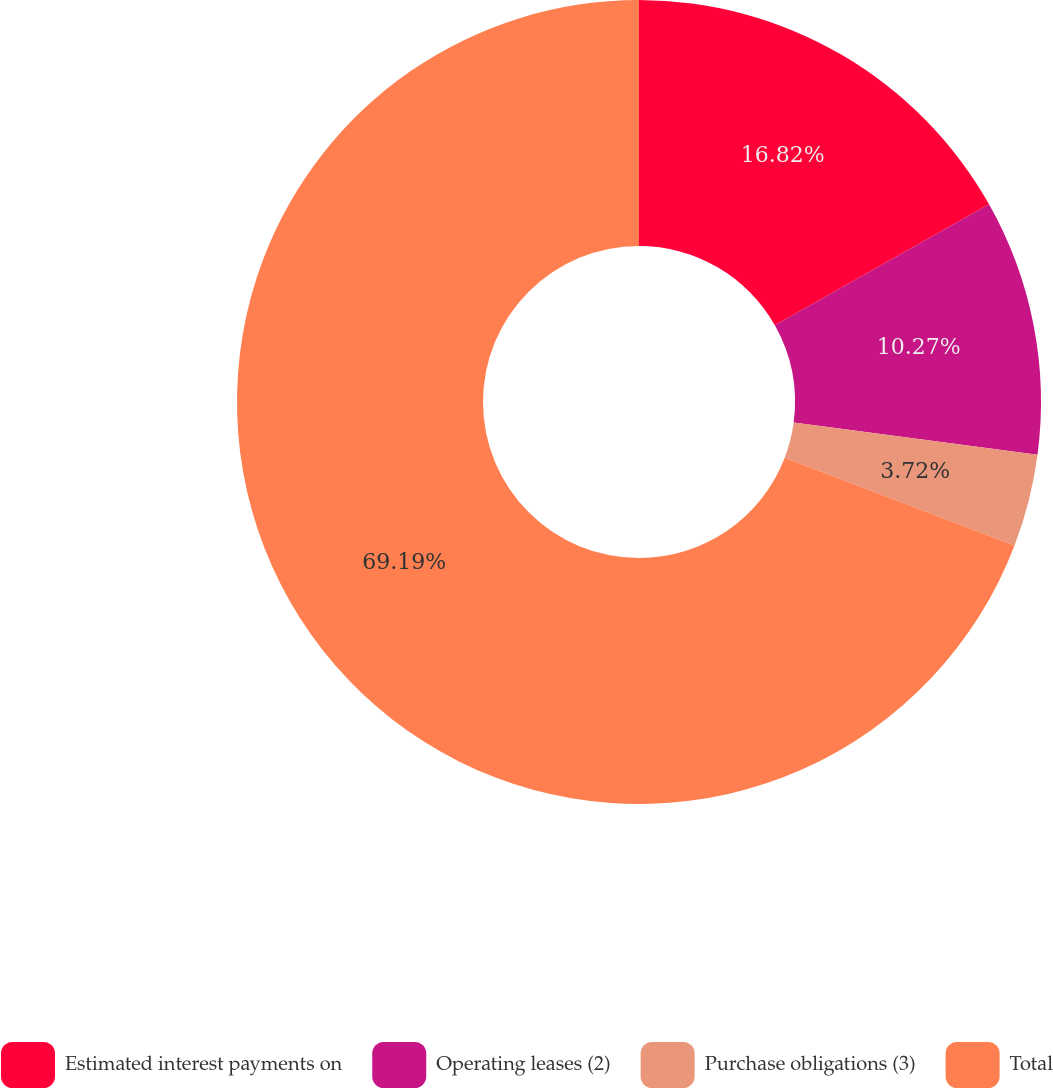Convert chart to OTSL. <chart><loc_0><loc_0><loc_500><loc_500><pie_chart><fcel>Estimated interest payments on<fcel>Operating leases (2)<fcel>Purchase obligations (3)<fcel>Total<nl><fcel>16.82%<fcel>10.27%<fcel>3.72%<fcel>69.19%<nl></chart> 